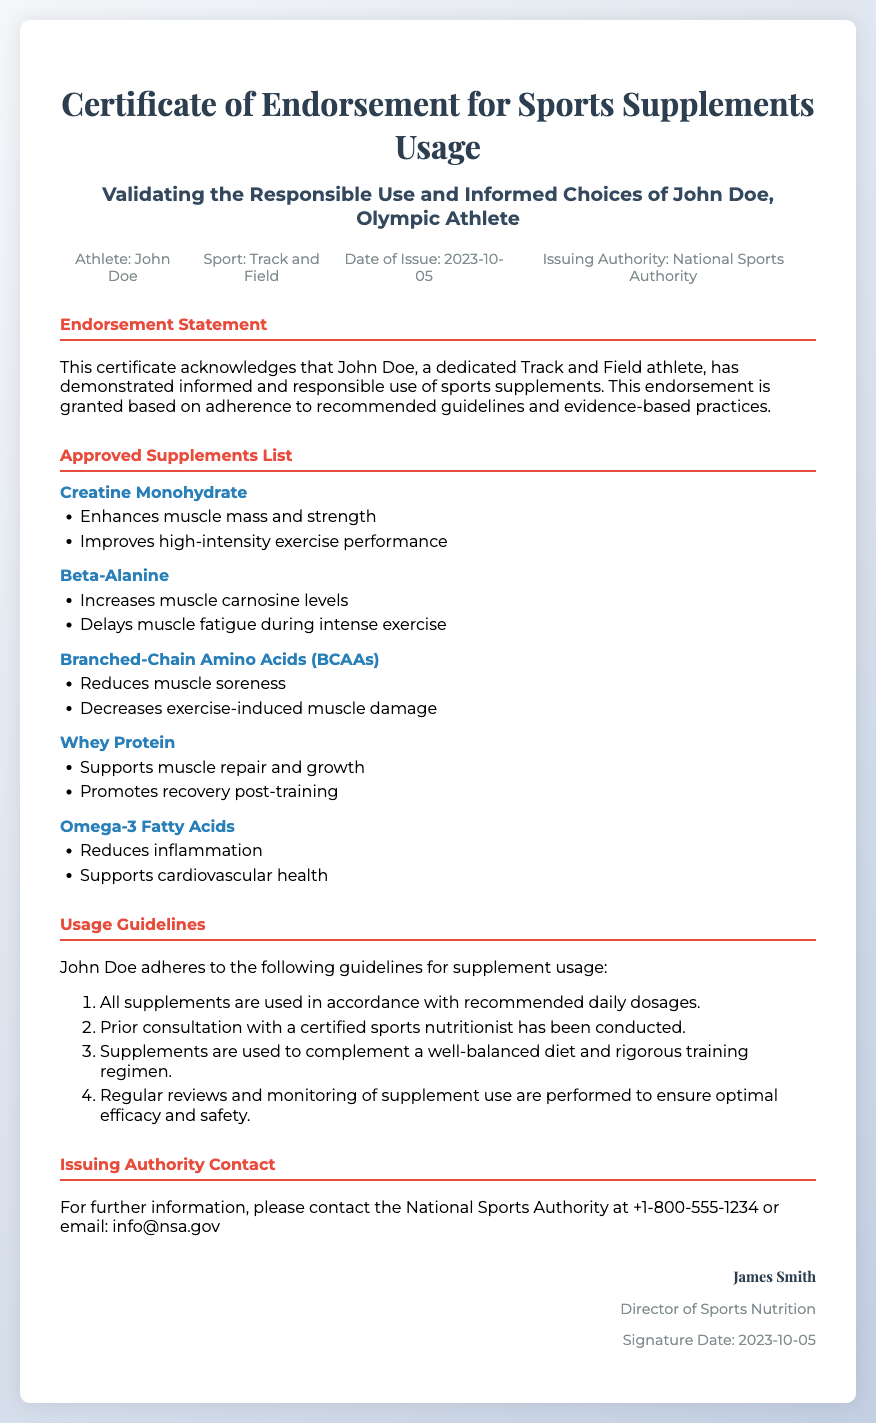What is the title of the certificate? The title of the certificate can be found at the top of the document.
Answer: Certificate of Endorsement for Sports Supplements Usage Who is the athlete mentioned in the document? The name of the athlete is mentioned in the header section of the document.
Answer: John Doe What is the sport of the athlete? The sport is specified in the athlete information section of the certificate.
Answer: Track and Field When was the certificate issued? The issuance date is listed in the athlete information section of the document.
Answer: 2023-10-05 Which authority issued the certificate? The authority responsible for issuing the certificate is identified in the certificate.
Answer: National Sports Authority Name one benefit of Creatine Monohydrate. The benefits of Creatine Monohydrate are outlined in the approved supplements section of the document.
Answer: Enhances muscle mass and strength How many usage guidelines are mentioned? The number of usage guidelines can be found by counting the items listed in the usage guidelines section.
Answer: 4 What is the contact number for the issuing authority? The contact information is provided in the issuing authority contact section of the document.
Answer: +1-800-555-1234 Who signed the certificate? The name of the person who signed the certificate is located at the bottom of the document.
Answer: James Smith 